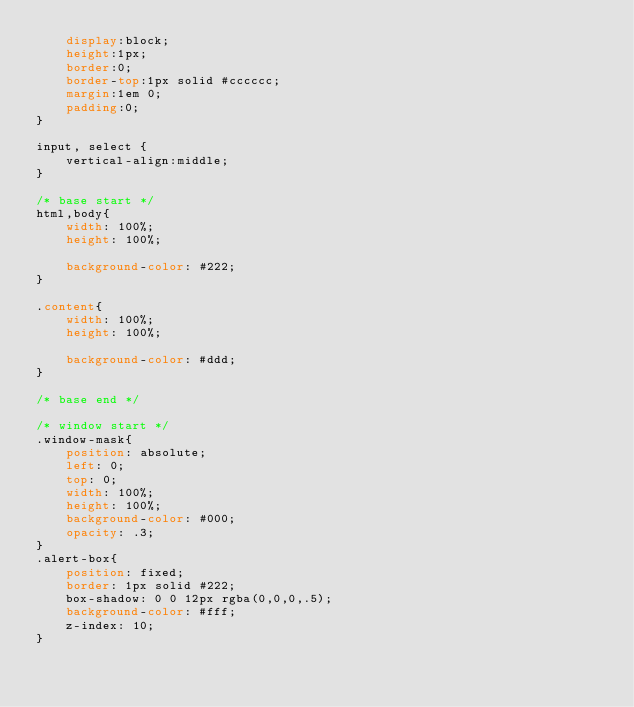<code> <loc_0><loc_0><loc_500><loc_500><_CSS_>    display:block;
    height:1px;
    border:0;
    border-top:1px solid #cccccc;
    margin:1em 0;
    padding:0;
}

input, select {
    vertical-align:middle;
}

/* base start */
html,body{
    width: 100%;
    height: 100%;

    background-color: #222;
}

.content{
    width: 100%;
    height: 100%;

    background-color: #ddd;
}

/* base end */

/* window start */
.window-mask{
    position: absolute;
    left: 0;
    top: 0;
    width: 100%;
    height: 100%;
    background-color: #000;
    opacity: .3;
}
.alert-box{
    position: fixed;
    border: 1px solid #222;
    box-shadow: 0 0 12px rgba(0,0,0,.5);
    background-color: #fff;
    z-index: 10;
}</code> 